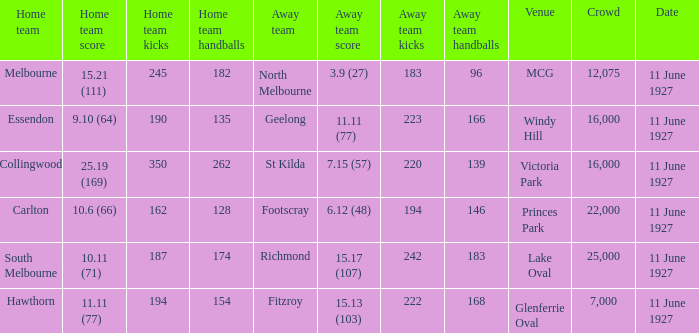What is the sum of all crowds present at the Glenferrie Oval venue? 7000.0. 